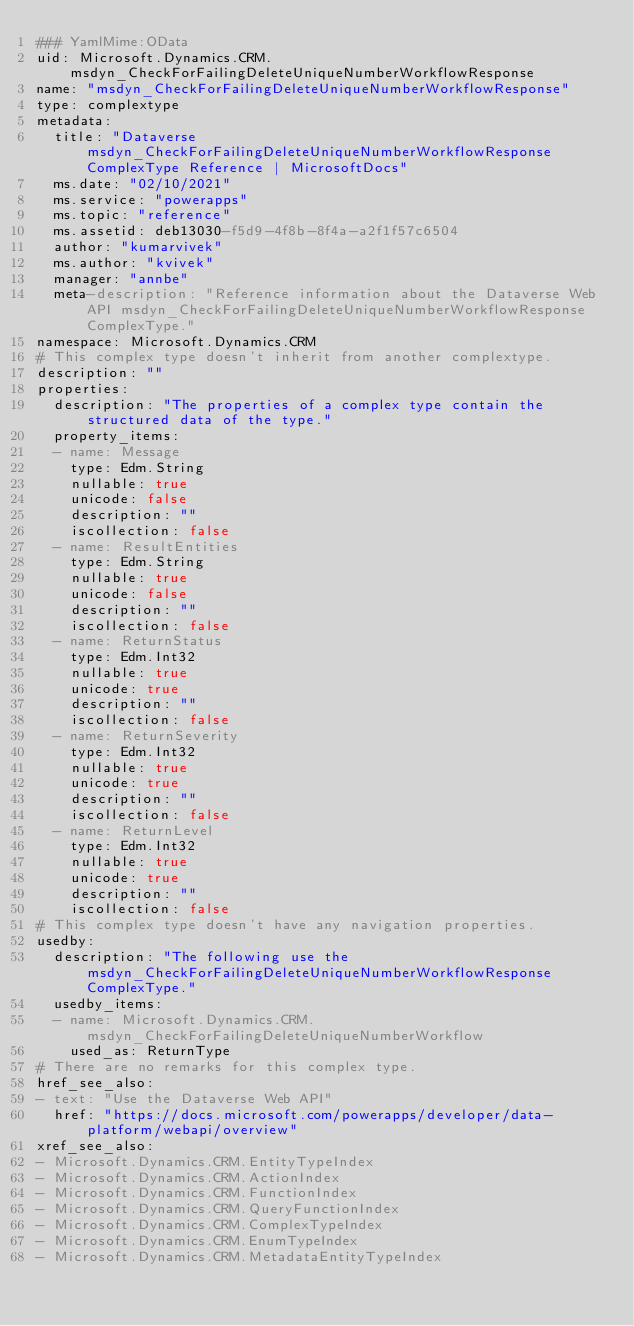Convert code to text. <code><loc_0><loc_0><loc_500><loc_500><_YAML_>### YamlMime:OData
uid: Microsoft.Dynamics.CRM.msdyn_CheckForFailingDeleteUniqueNumberWorkflowResponse
name: "msdyn_CheckForFailingDeleteUniqueNumberWorkflowResponse"
type: complextype
metadata: 
  title: "Dataverse msdyn_CheckForFailingDeleteUniqueNumberWorkflowResponse ComplexType Reference | MicrosoftDocs"
  ms.date: "02/10/2021"
  ms.service: "powerapps"
  ms.topic: "reference"
  ms.assetid: deb13030-f5d9-4f8b-8f4a-a2f1f57c6504
  author: "kumarvivek"
  ms.author: "kvivek"
  manager: "annbe"
  meta-description: "Reference information about the Dataverse Web API msdyn_CheckForFailingDeleteUniqueNumberWorkflowResponse ComplexType."
namespace: Microsoft.Dynamics.CRM
# This complex type doesn't inherit from another complextype.
description: "" 
properties:
  description: "The properties of a complex type contain the structured data of the type."
  property_items:
  - name: Message
    type: Edm.String
    nullable: true
    unicode: false
    description: ""
    iscollection: false
  - name: ResultEntities
    type: Edm.String
    nullable: true
    unicode: false
    description: ""
    iscollection: false
  - name: ReturnStatus
    type: Edm.Int32
    nullable: true
    unicode: true
    description: ""
    iscollection: false
  - name: ReturnSeverity
    type: Edm.Int32
    nullable: true
    unicode: true
    description: ""
    iscollection: false
  - name: ReturnLevel
    type: Edm.Int32
    nullable: true
    unicode: true
    description: ""
    iscollection: false
# This complex type doesn't have any navigation properties.
usedby:
  description: "The following use the msdyn_CheckForFailingDeleteUniqueNumberWorkflowResponse ComplexType."
  usedby_items:
  - name: Microsoft.Dynamics.CRM.msdyn_CheckForFailingDeleteUniqueNumberWorkflow
    used_as: ReturnType
# There are no remarks for this complex type.
href_see_also:
- text: "Use the Dataverse Web API"
  href: "https://docs.microsoft.com/powerapps/developer/data-platform/webapi/overview"
xref_see_also:
- Microsoft.Dynamics.CRM.EntityTypeIndex
- Microsoft.Dynamics.CRM.ActionIndex
- Microsoft.Dynamics.CRM.FunctionIndex
- Microsoft.Dynamics.CRM.QueryFunctionIndex
- Microsoft.Dynamics.CRM.ComplexTypeIndex
- Microsoft.Dynamics.CRM.EnumTypeIndex
- Microsoft.Dynamics.CRM.MetadataEntityTypeIndex</code> 